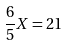Convert formula to latex. <formula><loc_0><loc_0><loc_500><loc_500>\frac { 6 } { 5 } X = 2 1</formula> 